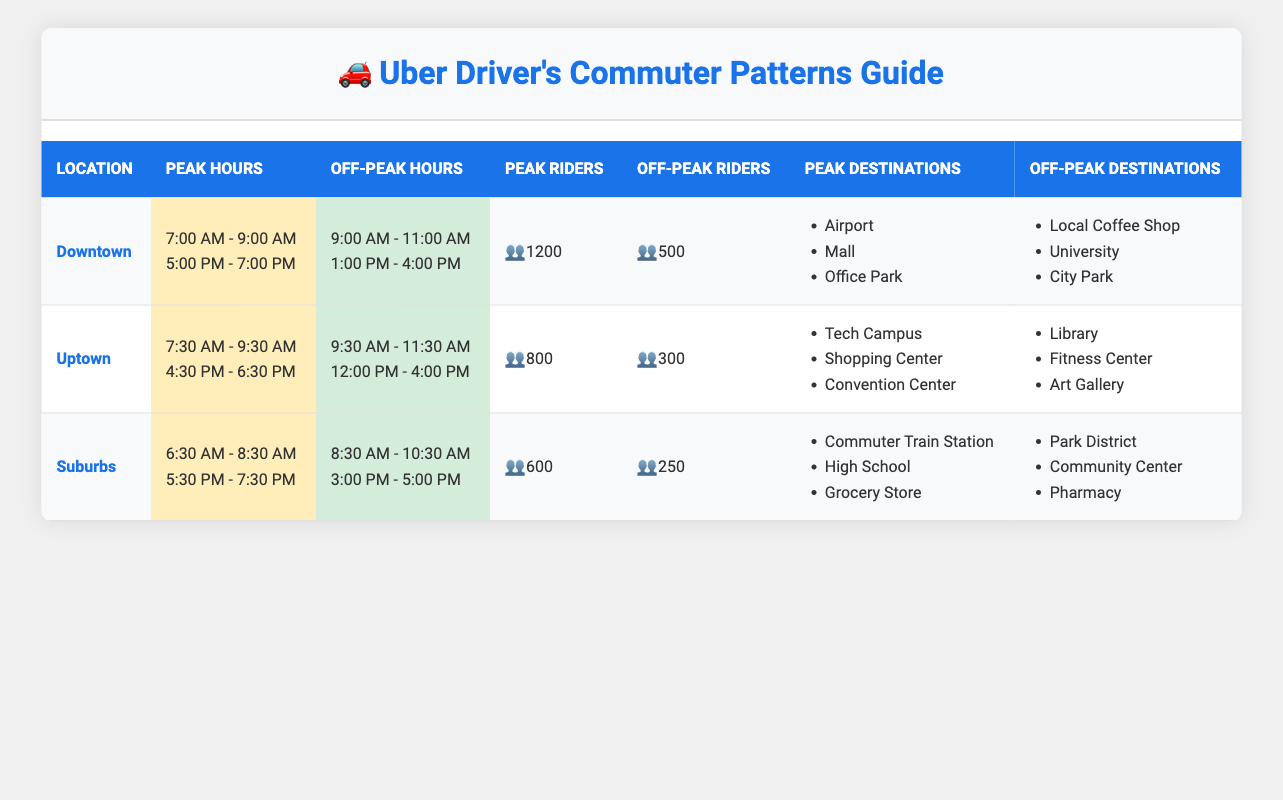What are the peak hours for Downtown? The peak hours for Downtown are 7:00 AM - 9:00 AM and 5:00 PM - 7:00 PM. This information can be found in the "Peak Hours" column for the Downtown location.
Answer: 7:00 AM - 9:00 AM and 5:00 PM - 7:00 PM How many average daily riders are there during off-peak hours in Uptown? The average daily riders during off-peak hours in Uptown is 300, as indicated in the "Off-Peak Riders" column for the Uptown location.
Answer: 300 Which location has the highest average daily riders during peak hours? To find out the highest average daily riders during peak hours, we compare the values for Downtown (1200), Uptown (800), and Suburbs (600). Downtown has the highest average daily riders at 1200.
Answer: Downtown What is the total number of average daily riders during peak hours for all locations? The total number of average daily riders during peak hours can be calculated by adding the values from each location: 1200 (Downtown) + 800 (Uptown) + 600 (Suburbs) = 2600.
Answer: 2600 Are there more average daily riders during peak hours in the Suburbs than off-peak hours? For the Suburbs, the average daily riders during peak hours is 600, while during off-peak hours it is 250. Since 600 is greater than 250, the statement is true.
Answer: Yes Which location has the least average daily riders during off-peak hours? We compare the average daily riders during off-peak hours: Downtown (500), Uptown (300), Suburbs (250). The Suburbs has the least average daily riders at 250.
Answer: Suburbs How many popular destinations are there for peak hours in Downtown? In Downtown, there are three popular destinations listed under peak hours: Airport, Mall, and Office Park. This is derived from the "Peak Destinations" column for Downtown.
Answer: 3 What is the difference in average daily riders between peak and off-peak hours for Uptown? For Uptown, the average daily riders during peak hours is 800 and during off-peak hours is 300. The difference can be calculated as 800 - 300 = 500.
Answer: 500 Which location has different popular destinations between peak and off-peak hours? In Downtown, the peak destinations are Airport, Mall, and Office Park, while off-peak destinations are Local Coffee Shop, University, and City Park. Since these lists differ, Downtown is the location with different popular destinations.
Answer: Downtown 